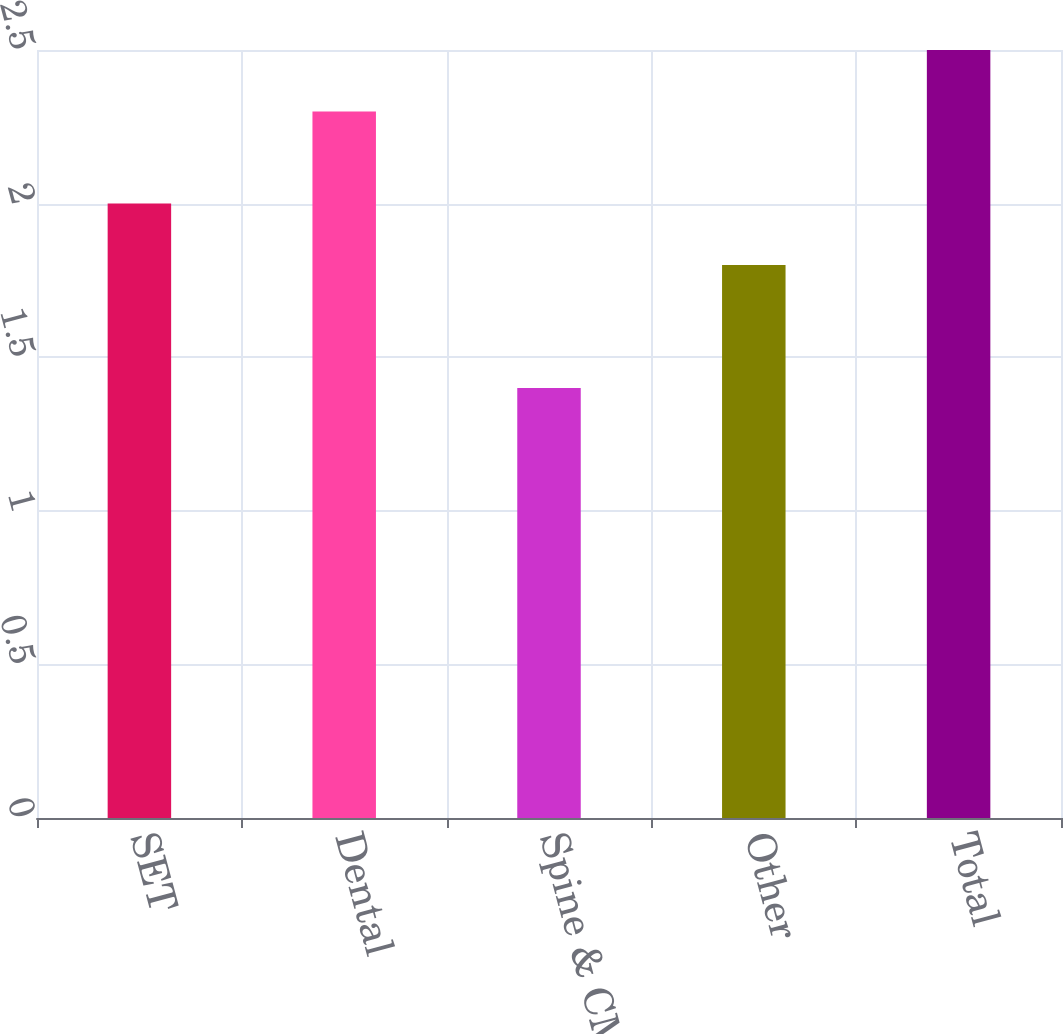Convert chart. <chart><loc_0><loc_0><loc_500><loc_500><bar_chart><fcel>SET<fcel>Dental<fcel>Spine & CMF<fcel>Other<fcel>Total<nl><fcel>2<fcel>2.3<fcel>1.4<fcel>1.8<fcel>2.5<nl></chart> 